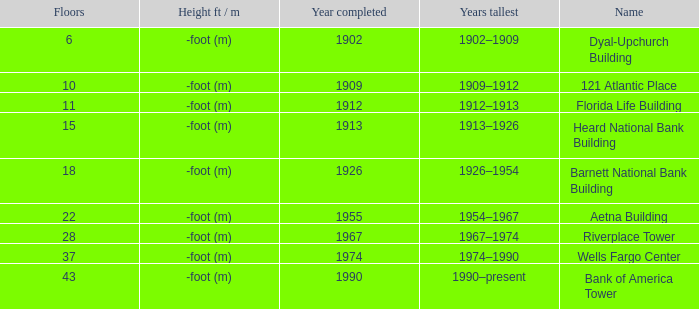How tall is the florida life building, completed before 1990? -foot (m). 